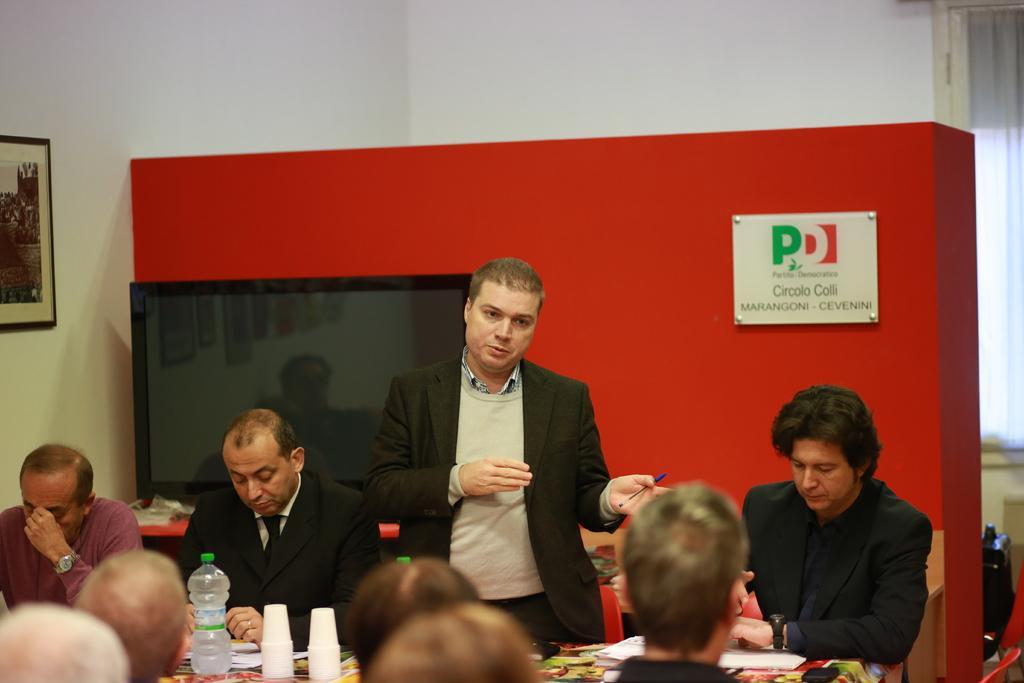Describe this image in one or two sentences. In this picture there are group of people those who are sitting around the table and there is a man who is standing in the center of the image is explaining about something with the help of his hands, there are bottles and glasses on the table, there is a television behind the man at the left side of the image and there is a portrait on the wall there is a red color board at the background of the image. 